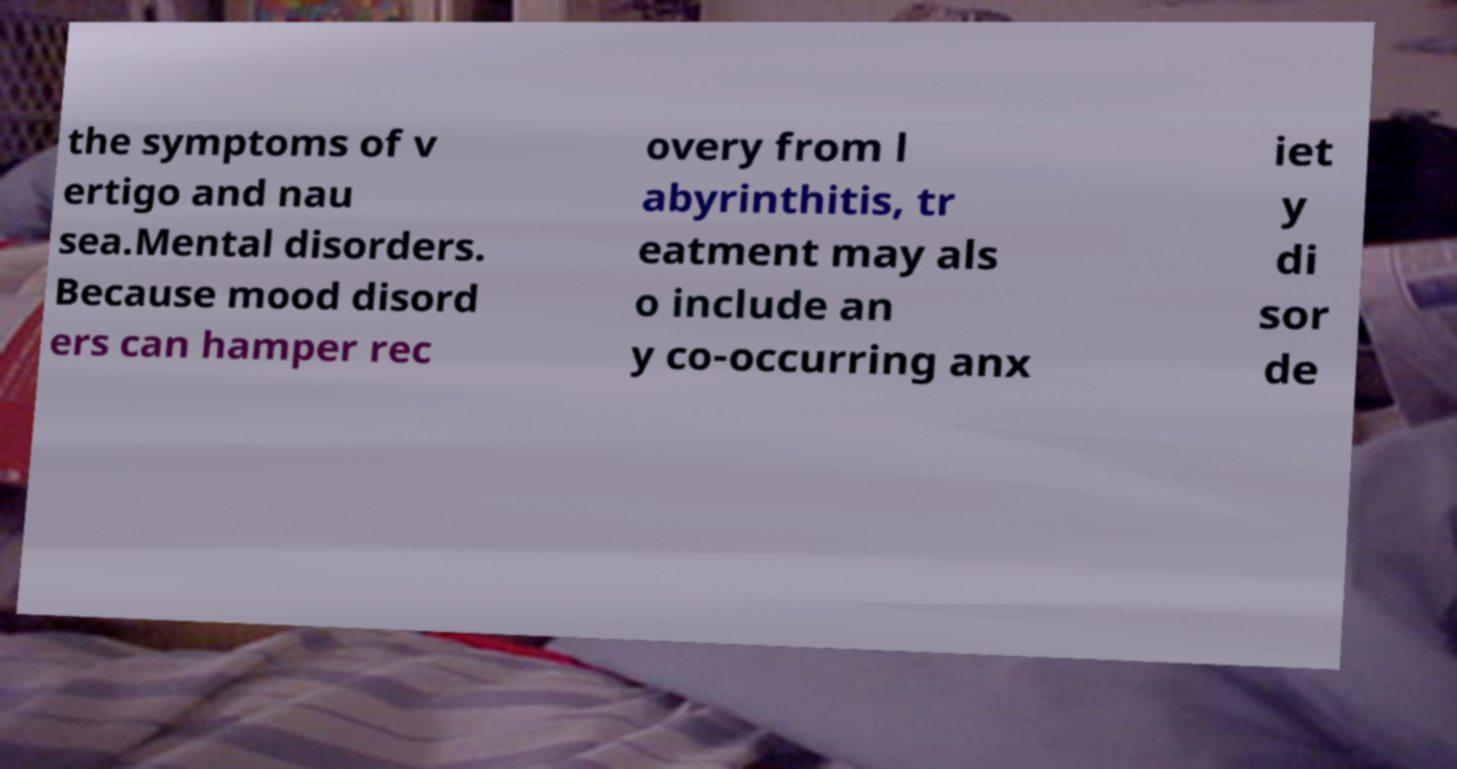Could you assist in decoding the text presented in this image and type it out clearly? the symptoms of v ertigo and nau sea.Mental disorders. Because mood disord ers can hamper rec overy from l abyrinthitis, tr eatment may als o include an y co-occurring anx iet y di sor de 